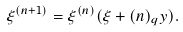Convert formula to latex. <formula><loc_0><loc_0><loc_500><loc_500>\xi ^ { ( n + 1 ) } = \xi ^ { ( n ) } ( \xi + ( n ) _ { q } y ) .</formula> 